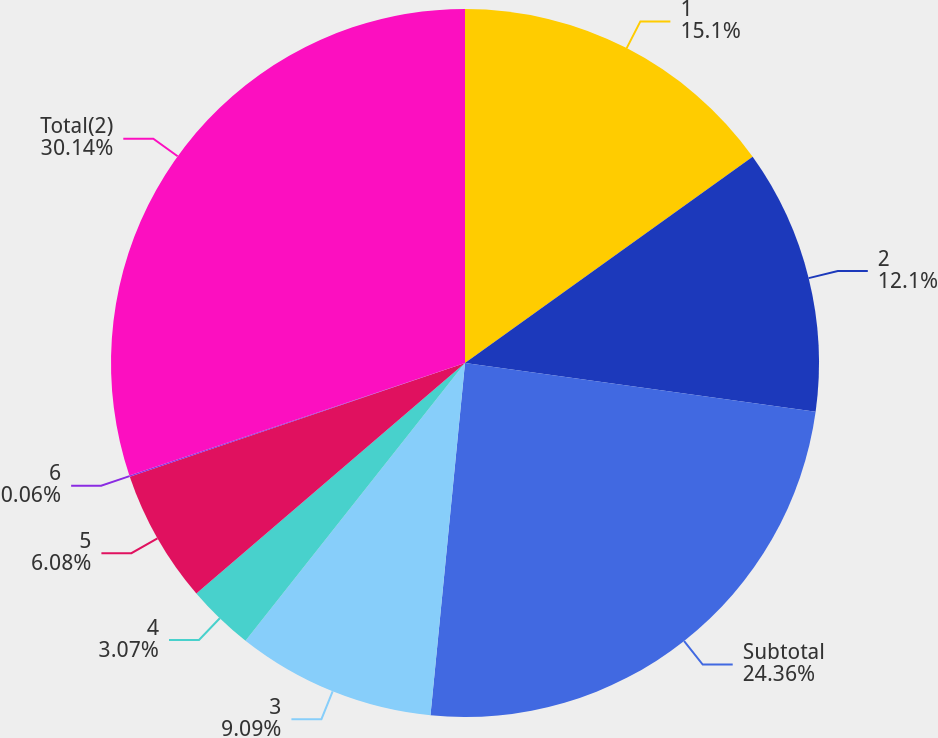Convert chart. <chart><loc_0><loc_0><loc_500><loc_500><pie_chart><fcel>1<fcel>2<fcel>Subtotal<fcel>3<fcel>4<fcel>5<fcel>6<fcel>Total(2)<nl><fcel>15.1%<fcel>12.1%<fcel>24.36%<fcel>9.09%<fcel>3.07%<fcel>6.08%<fcel>0.06%<fcel>30.15%<nl></chart> 